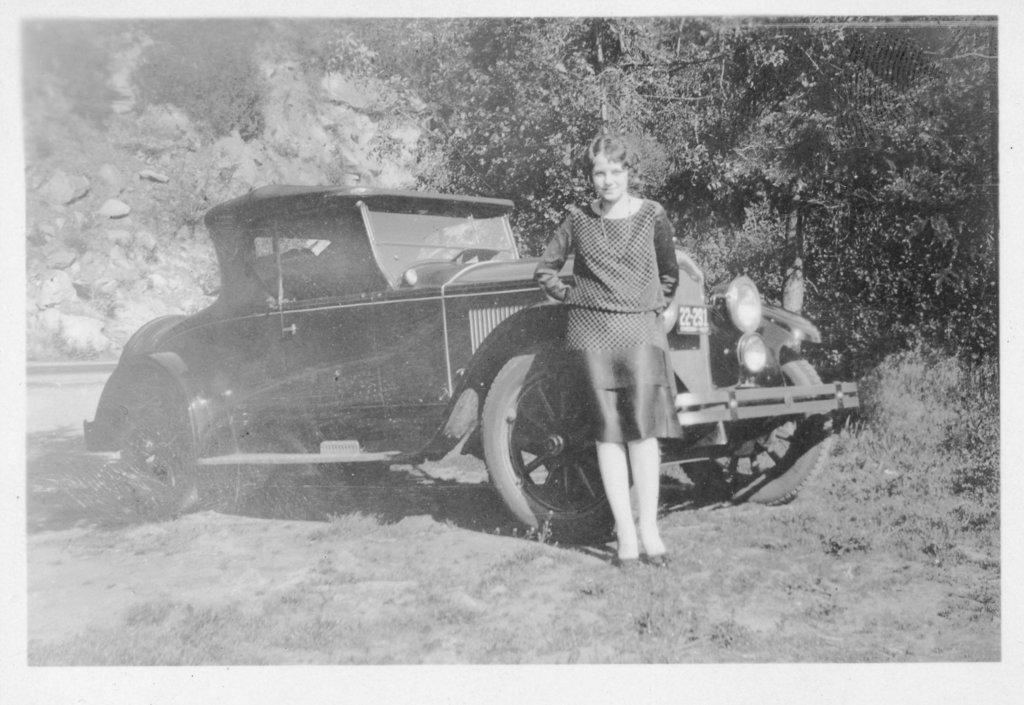How would you summarize this image in a sentence or two? This is a black and white image. In the center of the image there is a car. There is a lady. In the background of the image there are trees. At the bottom of the image there is grass. 